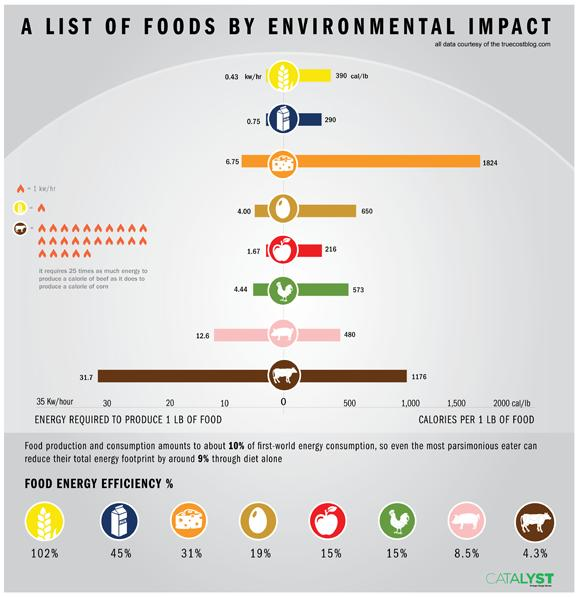Highlight a few significant elements in this photo. Approximately 1176 calories can be found in 1 pound of beef. The amount of calories in 1 pound of chicken is approximately 573 calories. The energy needed to produce 1 pound of beef is approximately 31.7 kilowatt hours. The egg or the chicken? When it comes to energy efficiency, it is the chicken that has a higher yield per unit of input energy. Approximately 290 calories are present in 1 pound of milk. 